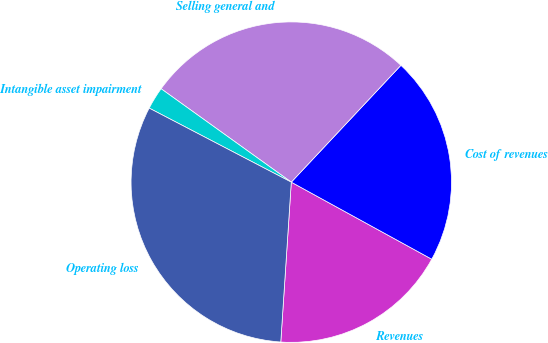Convert chart. <chart><loc_0><loc_0><loc_500><loc_500><pie_chart><fcel>Revenues<fcel>Cost of revenues<fcel>Selling general and<fcel>Intangible asset impairment<fcel>Operating loss<nl><fcel>18.06%<fcel>20.99%<fcel>27.09%<fcel>2.26%<fcel>31.6%<nl></chart> 